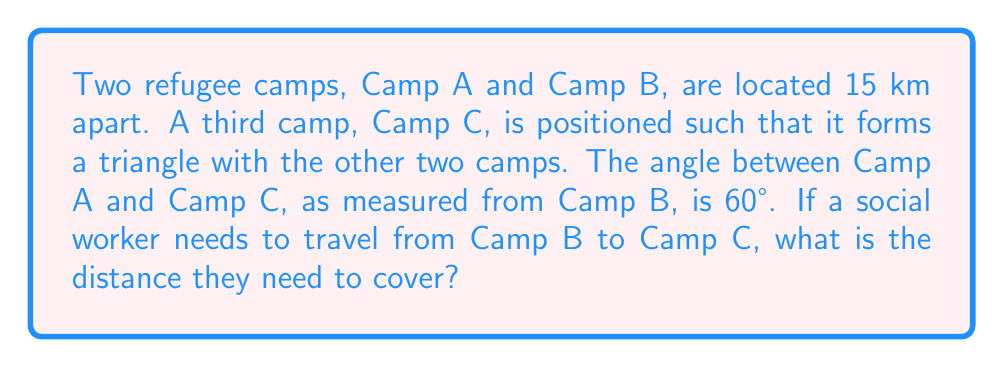What is the answer to this math problem? To solve this problem, we can use the law of cosines, which is ideal for solving triangles when we know two sides and the included angle.

Let's define our variables:
- $a$: distance from Camp B to Camp C (unknown)
- $b$: distance from Camp A to Camp C (not needed for this calculation)
- $c$: distance between Camp A and Camp B (given as 15 km)
- $\theta$: angle between Camp A and Camp C, as measured from Camp B (given as 60°)

The law of cosines states:

$$a^2 = b^2 + c^2 - 2bc \cos(\theta)$$

In our case, we don't need to know $b$, so we can simplify this to:

$$a^2 = c^2 + c^2 - 2c^2 \cos(\theta)$$

Substituting our known values:

$$a^2 = 15^2 + 15^2 - 2(15^2) \cos(60°)$$

Simplifying:
$$a^2 = 225 + 225 - 450 \cos(60°)$$

$$a^2 = 450 - 450 \cos(60°)$$

$$a^2 = 450 - 450 (0.5)$$  (since $\cos(60°) = 0.5$)

$$a^2 = 450 - 225 = 225$$

Taking the square root of both sides:

$$a = \sqrt{225} = 15$$

Therefore, the distance from Camp B to Camp C is 15 km.

[asy]
unitsize(0.2cm);
pair A = (0,0), B = (15,0), C = (15/2, 15*sin(pi/3));
draw(A--B--C--A);
label("A", A, SW);
label("B", B, SE);
label("C", C, N);
label("15 km", (A+B)/2, S);
label("15 km", (B+C)/2, NE);
label("60°", B, NW);
[/asy]
Answer: The distance from Camp B to Camp C is 15 km. 